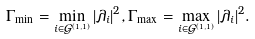Convert formula to latex. <formula><loc_0><loc_0><loc_500><loc_500>\Gamma _ { \min } = \min _ { i \in \mathcal { G } ^ { ( 1 , 1 ) } } | \lambda _ { i } | ^ { 2 } , & \, \Gamma _ { \max } = \max _ { i \in \mathcal { G } ^ { ( 1 , 1 ) } } | \lambda _ { i } | ^ { 2 } .</formula> 